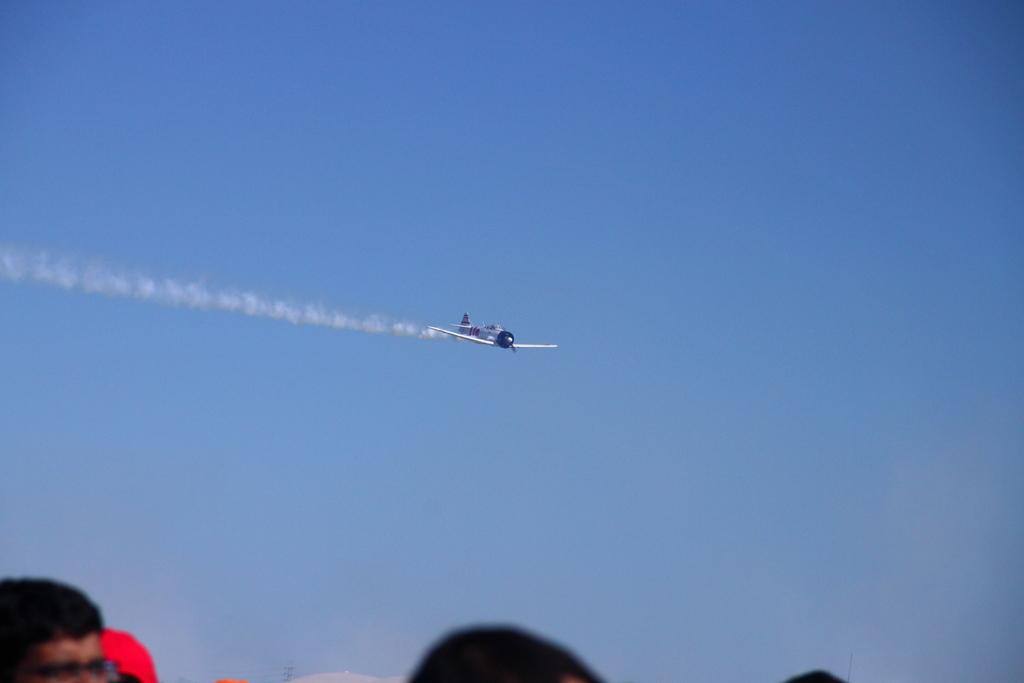What is the main subject of the image? The main subject of the image is an airplane. Where is the airplane located in the image? The airplane is in the air. What can be seen at the bottom of the image? There are people at the bottom of the image. What is visible in the background of the image? The sky is visible in the background of the image. Who is the manager of the airplane in the image? There is no indication of a manager or any personnel in the image; it simply shows an airplane in the air. What type of patch can be seen on the airplane's wing in the image? There is no patch visible on the airplane's wing in the image. 